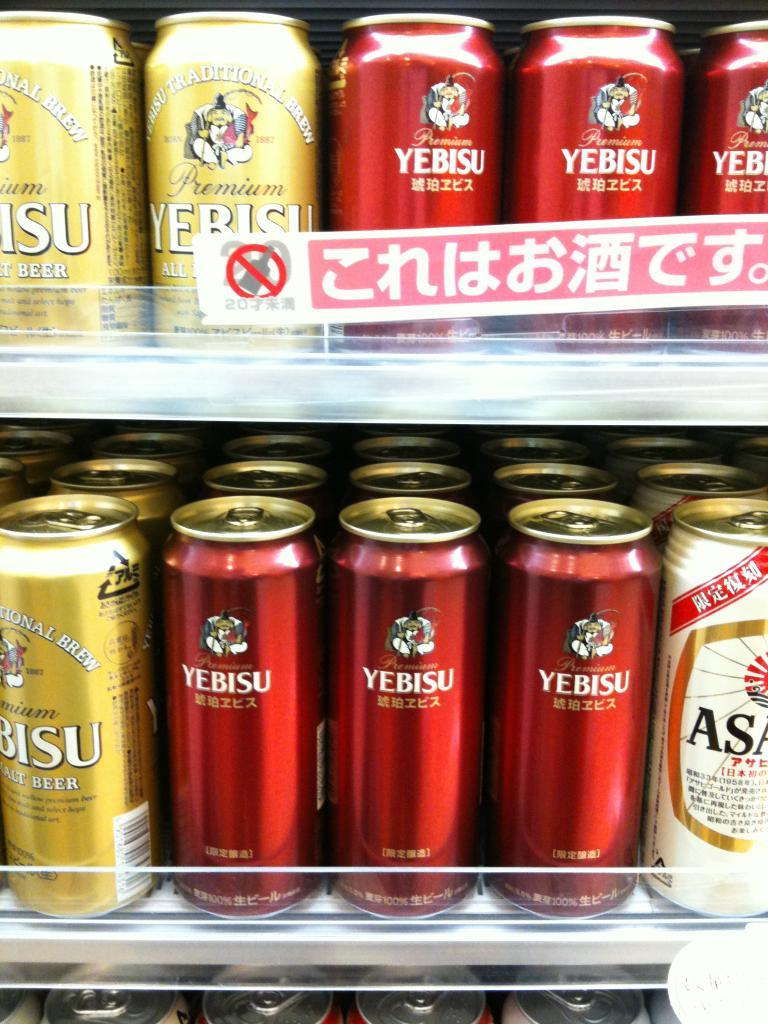<image>
Summarize the visual content of the image. a Yebisu can that is on some of the cans 